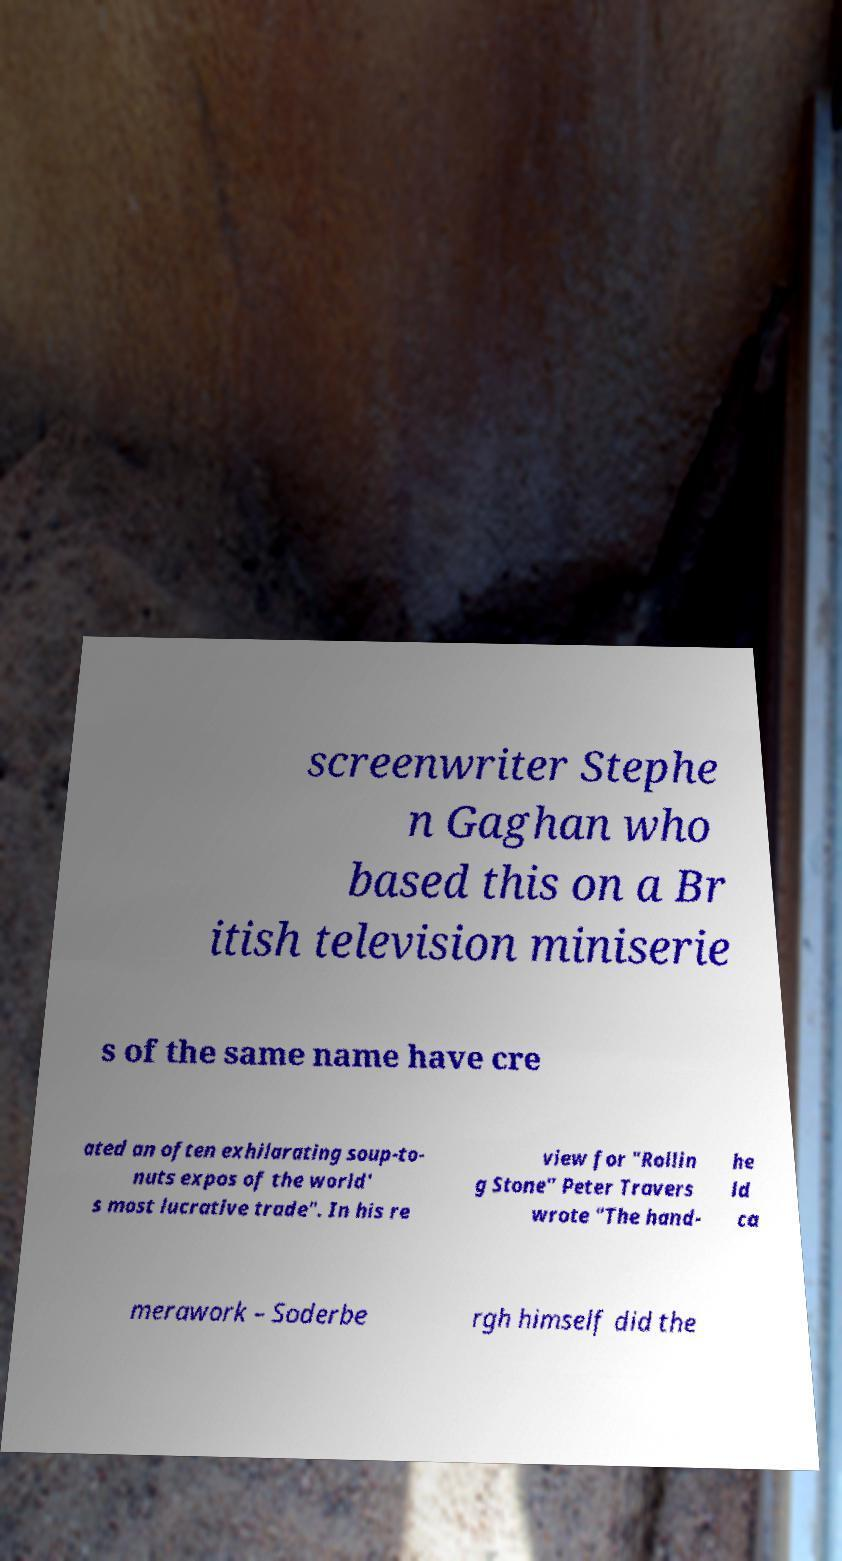I need the written content from this picture converted into text. Can you do that? screenwriter Stephe n Gaghan who based this on a Br itish television miniserie s of the same name have cre ated an often exhilarating soup-to- nuts expos of the world' s most lucrative trade". In his re view for "Rollin g Stone" Peter Travers wrote "The hand- he ld ca merawork – Soderbe rgh himself did the 